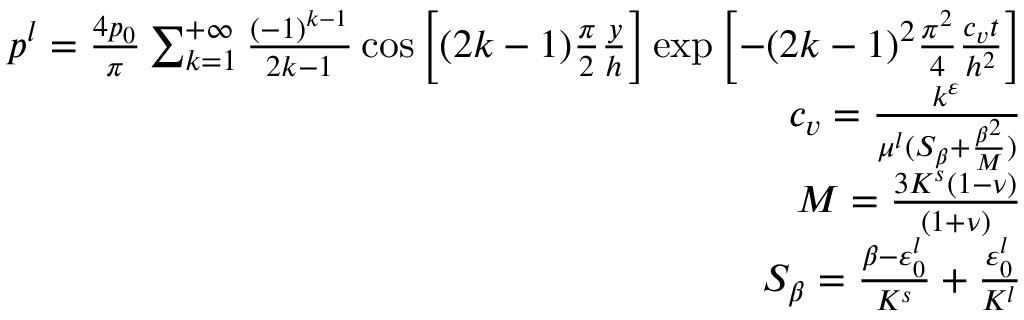<formula> <loc_0><loc_0><loc_500><loc_500>\begin{array} { r } { p ^ { l } = \frac { 4 p _ { 0 } } { \pi } \sum _ { k = 1 } ^ { + \infty } \frac { ( - 1 ) ^ { k - 1 } } { 2 k - 1 } \cos \left [ ( 2 k - 1 ) \frac { \pi } { 2 } \frac { y } { h } \right ] \exp \left [ - ( 2 k - 1 ) ^ { 2 } \frac { \pi ^ { 2 } } { 4 } \frac { c _ { v } t } { h ^ { 2 } } \right ] } \\ { c _ { v } = \frac { k ^ { \varepsilon } } { \mu ^ { l } ( S _ { \beta } + \frac { \beta ^ { 2 } } { M } ) } } \\ { M = \frac { 3 K ^ { s } ( 1 - \nu ) } { ( 1 + \nu ) } } \\ { S _ { \beta } = \frac { \beta - \varepsilon _ { 0 } ^ { l } } { K ^ { s } } + \frac { \varepsilon _ { 0 } ^ { l } } { K ^ { l } } } \end{array}</formula> 